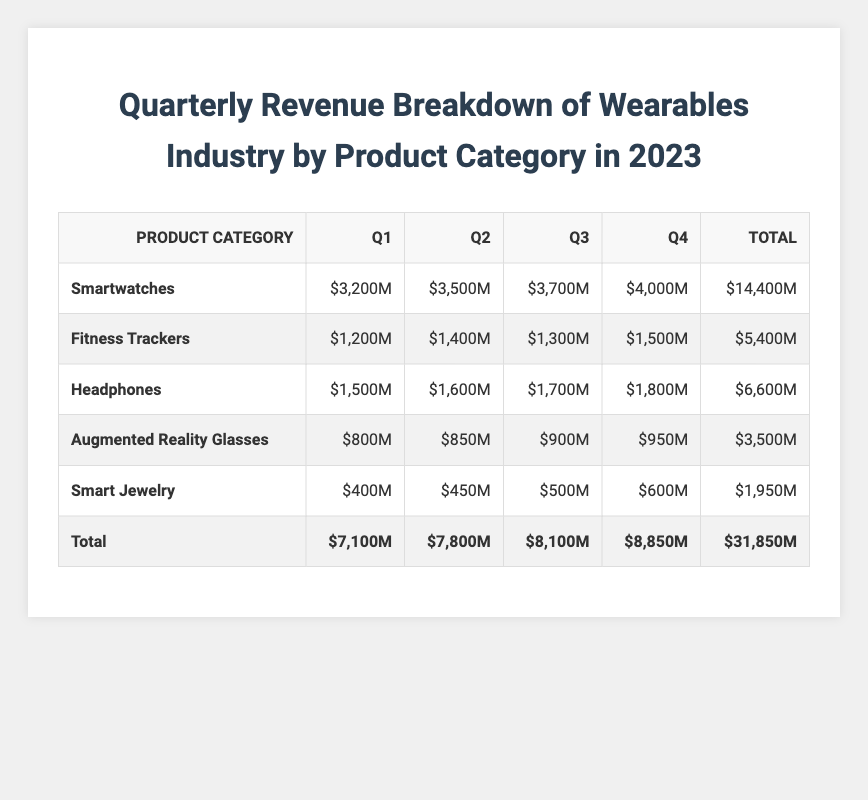What was the revenue from smartwatches in Q2? The revenue for smartwatches in Q2 is specified in the table as $3,500M.
Answer: $3,500M Which product category had the highest total revenue for the year? By looking at the total row, smartwatches have the highest total revenue at $14,400M.
Answer: Smartwatches What is the total revenue for headphones in Q4? According to the table, the revenue for headphones in Q4 is $1,800M.
Answer: $1,800M Calculate the average quarterly revenue for fitness trackers. The quarterly revenues for fitness trackers are $1,200M, $1,400M, $1,300M, and $1,500M. Adding these gives $5,400M, and dividing by 4 results in an average of $1,350M.
Answer: $1,350M Was the revenue from augmented reality glasses more than that from smart jewelry in Q1? The revenue for augmented reality glasses in Q1 is $800M, while smart jewelry's revenue is $400M. Since $800M is greater than $400M, the statement is true.
Answer: Yes What is the difference in revenue between Q3 and Q4 for headphones? The Q3 revenue for headphones is $1,700M and for Q4 it is $1,800M. The difference is calculated as $1,800M - $1,700M, which equals $100M.
Answer: $100M What was the total revenue for the wearables industry in Q1? The total revenue for Q1 is recorded in the total row as $7,100M.
Answer: $7,100M How much did smart jewelry earn in total throughout 2023? The total revenue for smart jewelry in the total row is $1,950M.
Answer: $1,950M Compare the revenue growth for smartwatches between Q1 and Q4. In Q1, the revenue for smartwatches was $3,200M, and in Q4 it grew to $4,000M. The growth can be calculated as $4,000M - $3,200M = $800M.
Answer: $800M Which product category showed consistent growth throughout the four quarters? Smartwatches showed consistent growth with revenues increasing each quarter: $3,200M in Q1, $3,500M in Q2, $3,700M in Q3, and $4,000M in Q4.
Answer: Yes 